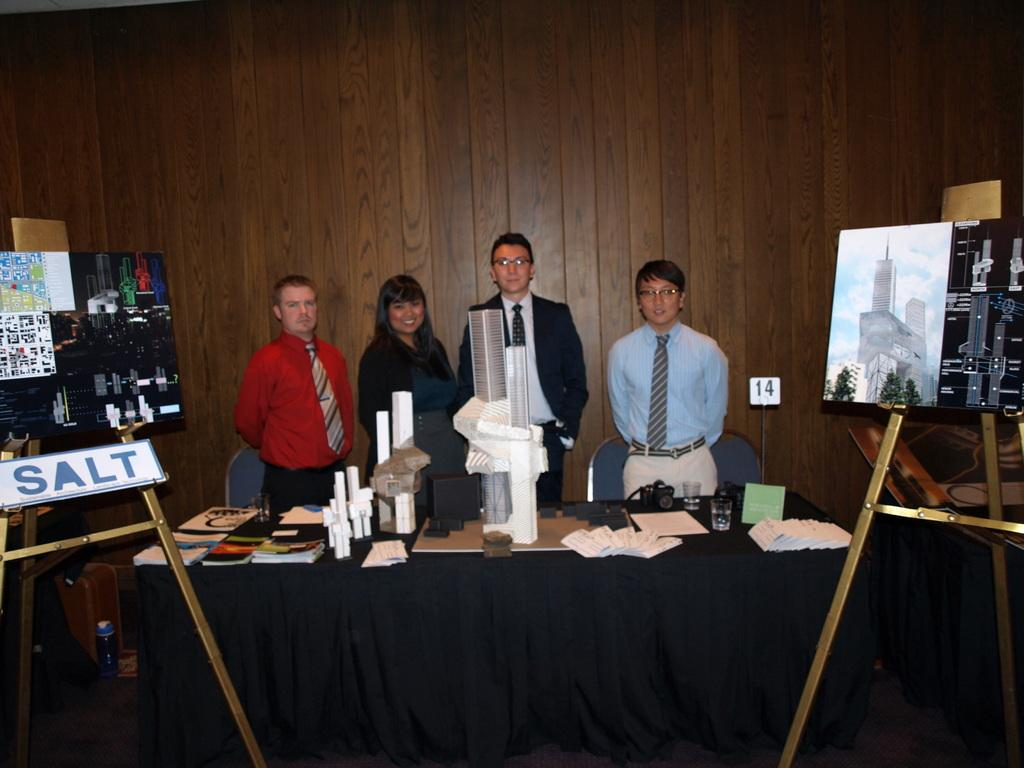How many people are present in the image? There are four people standing in the image. What can be seen on the table in the image? There is a book, materials, a camera, and a glass on the table. What else is present in the image besides the people and the table? There is a board in the image. Can you see a baseball being used by one of the people in the image? There is no baseball present in the image. Are any of the people smiling in the image? The provided facts do not mention the facial expressions of the people, so it cannot be determined if they are smiling or not. 